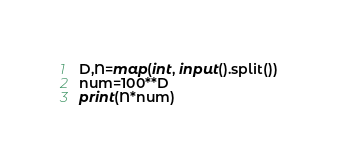Convert code to text. <code><loc_0><loc_0><loc_500><loc_500><_Python_>D,N=map(int, input().split())
num=100**D
print(N*num)</code> 